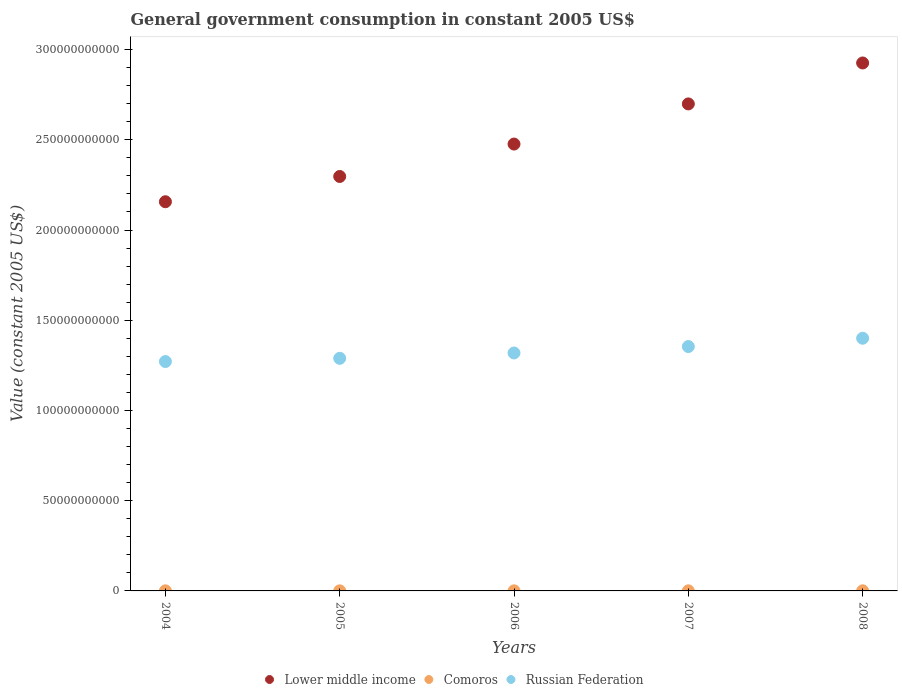Is the number of dotlines equal to the number of legend labels?
Your answer should be very brief. Yes. What is the government conusmption in Comoros in 2005?
Provide a short and direct response. 4.92e+07. Across all years, what is the maximum government conusmption in Lower middle income?
Ensure brevity in your answer.  2.93e+11. Across all years, what is the minimum government conusmption in Comoros?
Ensure brevity in your answer.  4.92e+07. In which year was the government conusmption in Lower middle income maximum?
Provide a succinct answer. 2008. In which year was the government conusmption in Lower middle income minimum?
Your answer should be very brief. 2004. What is the total government conusmption in Russian Federation in the graph?
Your answer should be compact. 6.63e+11. What is the difference between the government conusmption in Lower middle income in 2006 and that in 2007?
Give a very brief answer. -2.22e+1. What is the difference between the government conusmption in Russian Federation in 2004 and the government conusmption in Comoros in 2008?
Keep it short and to the point. 1.27e+11. What is the average government conusmption in Lower middle income per year?
Provide a short and direct response. 2.51e+11. In the year 2007, what is the difference between the government conusmption in Russian Federation and government conusmption in Comoros?
Provide a succinct answer. 1.35e+11. In how many years, is the government conusmption in Comoros greater than 30000000000 US$?
Your answer should be compact. 0. What is the ratio of the government conusmption in Comoros in 2007 to that in 2008?
Your answer should be very brief. 0.8. Is the government conusmption in Lower middle income in 2005 less than that in 2007?
Keep it short and to the point. Yes. What is the difference between the highest and the second highest government conusmption in Lower middle income?
Give a very brief answer. 2.27e+1. What is the difference between the highest and the lowest government conusmption in Lower middle income?
Offer a very short reply. 7.69e+1. In how many years, is the government conusmption in Comoros greater than the average government conusmption in Comoros taken over all years?
Keep it short and to the point. 2. Is the sum of the government conusmption in Russian Federation in 2004 and 2008 greater than the maximum government conusmption in Lower middle income across all years?
Your response must be concise. No. Is the government conusmption in Comoros strictly greater than the government conusmption in Russian Federation over the years?
Ensure brevity in your answer.  No. How many dotlines are there?
Provide a succinct answer. 3. How many years are there in the graph?
Provide a short and direct response. 5. What is the difference between two consecutive major ticks on the Y-axis?
Your answer should be compact. 5.00e+1. Are the values on the major ticks of Y-axis written in scientific E-notation?
Your answer should be compact. No. Does the graph contain grids?
Your answer should be compact. No. How many legend labels are there?
Your answer should be compact. 3. How are the legend labels stacked?
Your answer should be very brief. Horizontal. What is the title of the graph?
Offer a terse response. General government consumption in constant 2005 US$. What is the label or title of the Y-axis?
Offer a terse response. Value (constant 2005 US$). What is the Value (constant 2005 US$) of Lower middle income in 2004?
Offer a very short reply. 2.16e+11. What is the Value (constant 2005 US$) of Comoros in 2004?
Offer a very short reply. 5.04e+07. What is the Value (constant 2005 US$) in Russian Federation in 2004?
Provide a short and direct response. 1.27e+11. What is the Value (constant 2005 US$) in Lower middle income in 2005?
Keep it short and to the point. 2.30e+11. What is the Value (constant 2005 US$) of Comoros in 2005?
Ensure brevity in your answer.  4.92e+07. What is the Value (constant 2005 US$) in Russian Federation in 2005?
Provide a short and direct response. 1.29e+11. What is the Value (constant 2005 US$) in Lower middle income in 2006?
Offer a very short reply. 2.48e+11. What is the Value (constant 2005 US$) in Comoros in 2006?
Offer a very short reply. 4.92e+07. What is the Value (constant 2005 US$) in Russian Federation in 2006?
Your answer should be compact. 1.32e+11. What is the Value (constant 2005 US$) in Lower middle income in 2007?
Make the answer very short. 2.70e+11. What is the Value (constant 2005 US$) of Comoros in 2007?
Your answer should be compact. 5.63e+07. What is the Value (constant 2005 US$) in Russian Federation in 2007?
Your response must be concise. 1.35e+11. What is the Value (constant 2005 US$) in Lower middle income in 2008?
Your answer should be compact. 2.93e+11. What is the Value (constant 2005 US$) in Comoros in 2008?
Ensure brevity in your answer.  7.03e+07. What is the Value (constant 2005 US$) of Russian Federation in 2008?
Keep it short and to the point. 1.40e+11. Across all years, what is the maximum Value (constant 2005 US$) of Lower middle income?
Offer a terse response. 2.93e+11. Across all years, what is the maximum Value (constant 2005 US$) of Comoros?
Your answer should be compact. 7.03e+07. Across all years, what is the maximum Value (constant 2005 US$) in Russian Federation?
Give a very brief answer. 1.40e+11. Across all years, what is the minimum Value (constant 2005 US$) in Lower middle income?
Give a very brief answer. 2.16e+11. Across all years, what is the minimum Value (constant 2005 US$) of Comoros?
Your response must be concise. 4.92e+07. Across all years, what is the minimum Value (constant 2005 US$) of Russian Federation?
Give a very brief answer. 1.27e+11. What is the total Value (constant 2005 US$) in Lower middle income in the graph?
Provide a succinct answer. 1.26e+12. What is the total Value (constant 2005 US$) in Comoros in the graph?
Offer a very short reply. 2.75e+08. What is the total Value (constant 2005 US$) of Russian Federation in the graph?
Make the answer very short. 6.63e+11. What is the difference between the Value (constant 2005 US$) in Lower middle income in 2004 and that in 2005?
Your response must be concise. -1.40e+1. What is the difference between the Value (constant 2005 US$) of Comoros in 2004 and that in 2005?
Offer a terse response. 1.22e+06. What is the difference between the Value (constant 2005 US$) in Russian Federation in 2004 and that in 2005?
Provide a short and direct response. -1.78e+09. What is the difference between the Value (constant 2005 US$) of Lower middle income in 2004 and that in 2006?
Provide a short and direct response. -3.20e+1. What is the difference between the Value (constant 2005 US$) in Comoros in 2004 and that in 2006?
Give a very brief answer. 1.20e+06. What is the difference between the Value (constant 2005 US$) in Russian Federation in 2004 and that in 2006?
Keep it short and to the point. -4.74e+09. What is the difference between the Value (constant 2005 US$) of Lower middle income in 2004 and that in 2007?
Provide a short and direct response. -5.42e+1. What is the difference between the Value (constant 2005 US$) of Comoros in 2004 and that in 2007?
Make the answer very short. -5.85e+06. What is the difference between the Value (constant 2005 US$) of Russian Federation in 2004 and that in 2007?
Your response must be concise. -8.30e+09. What is the difference between the Value (constant 2005 US$) in Lower middle income in 2004 and that in 2008?
Make the answer very short. -7.69e+1. What is the difference between the Value (constant 2005 US$) of Comoros in 2004 and that in 2008?
Give a very brief answer. -1.99e+07. What is the difference between the Value (constant 2005 US$) of Russian Federation in 2004 and that in 2008?
Give a very brief answer. -1.29e+1. What is the difference between the Value (constant 2005 US$) in Lower middle income in 2005 and that in 2006?
Provide a succinct answer. -1.80e+1. What is the difference between the Value (constant 2005 US$) of Comoros in 2005 and that in 2006?
Offer a very short reply. -2.12e+04. What is the difference between the Value (constant 2005 US$) in Russian Federation in 2005 and that in 2006?
Provide a succinct answer. -2.96e+09. What is the difference between the Value (constant 2005 US$) in Lower middle income in 2005 and that in 2007?
Provide a succinct answer. -4.02e+1. What is the difference between the Value (constant 2005 US$) of Comoros in 2005 and that in 2007?
Your answer should be compact. -7.07e+06. What is the difference between the Value (constant 2005 US$) of Russian Federation in 2005 and that in 2007?
Give a very brief answer. -6.53e+09. What is the difference between the Value (constant 2005 US$) in Lower middle income in 2005 and that in 2008?
Provide a succinct answer. -6.29e+1. What is the difference between the Value (constant 2005 US$) of Comoros in 2005 and that in 2008?
Offer a very short reply. -2.11e+07. What is the difference between the Value (constant 2005 US$) of Russian Federation in 2005 and that in 2008?
Ensure brevity in your answer.  -1.11e+1. What is the difference between the Value (constant 2005 US$) in Lower middle income in 2006 and that in 2007?
Keep it short and to the point. -2.22e+1. What is the difference between the Value (constant 2005 US$) in Comoros in 2006 and that in 2007?
Your answer should be compact. -7.05e+06. What is the difference between the Value (constant 2005 US$) in Russian Federation in 2006 and that in 2007?
Provide a short and direct response. -3.56e+09. What is the difference between the Value (constant 2005 US$) in Lower middle income in 2006 and that in 2008?
Offer a very short reply. -4.49e+1. What is the difference between the Value (constant 2005 US$) of Comoros in 2006 and that in 2008?
Your response must be concise. -2.11e+07. What is the difference between the Value (constant 2005 US$) in Russian Federation in 2006 and that in 2008?
Ensure brevity in your answer.  -8.16e+09. What is the difference between the Value (constant 2005 US$) of Lower middle income in 2007 and that in 2008?
Make the answer very short. -2.27e+1. What is the difference between the Value (constant 2005 US$) in Comoros in 2007 and that in 2008?
Your answer should be compact. -1.41e+07. What is the difference between the Value (constant 2005 US$) in Russian Federation in 2007 and that in 2008?
Give a very brief answer. -4.60e+09. What is the difference between the Value (constant 2005 US$) of Lower middle income in 2004 and the Value (constant 2005 US$) of Comoros in 2005?
Provide a succinct answer. 2.16e+11. What is the difference between the Value (constant 2005 US$) in Lower middle income in 2004 and the Value (constant 2005 US$) in Russian Federation in 2005?
Your response must be concise. 8.68e+1. What is the difference between the Value (constant 2005 US$) in Comoros in 2004 and the Value (constant 2005 US$) in Russian Federation in 2005?
Ensure brevity in your answer.  -1.29e+11. What is the difference between the Value (constant 2005 US$) of Lower middle income in 2004 and the Value (constant 2005 US$) of Comoros in 2006?
Ensure brevity in your answer.  2.16e+11. What is the difference between the Value (constant 2005 US$) of Lower middle income in 2004 and the Value (constant 2005 US$) of Russian Federation in 2006?
Your answer should be compact. 8.38e+1. What is the difference between the Value (constant 2005 US$) of Comoros in 2004 and the Value (constant 2005 US$) of Russian Federation in 2006?
Keep it short and to the point. -1.32e+11. What is the difference between the Value (constant 2005 US$) in Lower middle income in 2004 and the Value (constant 2005 US$) in Comoros in 2007?
Make the answer very short. 2.16e+11. What is the difference between the Value (constant 2005 US$) of Lower middle income in 2004 and the Value (constant 2005 US$) of Russian Federation in 2007?
Offer a very short reply. 8.02e+1. What is the difference between the Value (constant 2005 US$) in Comoros in 2004 and the Value (constant 2005 US$) in Russian Federation in 2007?
Your response must be concise. -1.35e+11. What is the difference between the Value (constant 2005 US$) of Lower middle income in 2004 and the Value (constant 2005 US$) of Comoros in 2008?
Make the answer very short. 2.16e+11. What is the difference between the Value (constant 2005 US$) in Lower middle income in 2004 and the Value (constant 2005 US$) in Russian Federation in 2008?
Your response must be concise. 7.56e+1. What is the difference between the Value (constant 2005 US$) of Comoros in 2004 and the Value (constant 2005 US$) of Russian Federation in 2008?
Your answer should be very brief. -1.40e+11. What is the difference between the Value (constant 2005 US$) in Lower middle income in 2005 and the Value (constant 2005 US$) in Comoros in 2006?
Provide a succinct answer. 2.30e+11. What is the difference between the Value (constant 2005 US$) in Lower middle income in 2005 and the Value (constant 2005 US$) in Russian Federation in 2006?
Offer a very short reply. 9.78e+1. What is the difference between the Value (constant 2005 US$) of Comoros in 2005 and the Value (constant 2005 US$) of Russian Federation in 2006?
Your answer should be very brief. -1.32e+11. What is the difference between the Value (constant 2005 US$) of Lower middle income in 2005 and the Value (constant 2005 US$) of Comoros in 2007?
Keep it short and to the point. 2.30e+11. What is the difference between the Value (constant 2005 US$) of Lower middle income in 2005 and the Value (constant 2005 US$) of Russian Federation in 2007?
Provide a succinct answer. 9.43e+1. What is the difference between the Value (constant 2005 US$) of Comoros in 2005 and the Value (constant 2005 US$) of Russian Federation in 2007?
Ensure brevity in your answer.  -1.35e+11. What is the difference between the Value (constant 2005 US$) in Lower middle income in 2005 and the Value (constant 2005 US$) in Comoros in 2008?
Keep it short and to the point. 2.30e+11. What is the difference between the Value (constant 2005 US$) of Lower middle income in 2005 and the Value (constant 2005 US$) of Russian Federation in 2008?
Your response must be concise. 8.96e+1. What is the difference between the Value (constant 2005 US$) of Comoros in 2005 and the Value (constant 2005 US$) of Russian Federation in 2008?
Your answer should be compact. -1.40e+11. What is the difference between the Value (constant 2005 US$) in Lower middle income in 2006 and the Value (constant 2005 US$) in Comoros in 2007?
Your answer should be very brief. 2.48e+11. What is the difference between the Value (constant 2005 US$) of Lower middle income in 2006 and the Value (constant 2005 US$) of Russian Federation in 2007?
Offer a very short reply. 1.12e+11. What is the difference between the Value (constant 2005 US$) in Comoros in 2006 and the Value (constant 2005 US$) in Russian Federation in 2007?
Provide a succinct answer. -1.35e+11. What is the difference between the Value (constant 2005 US$) in Lower middle income in 2006 and the Value (constant 2005 US$) in Comoros in 2008?
Ensure brevity in your answer.  2.48e+11. What is the difference between the Value (constant 2005 US$) of Lower middle income in 2006 and the Value (constant 2005 US$) of Russian Federation in 2008?
Keep it short and to the point. 1.08e+11. What is the difference between the Value (constant 2005 US$) of Comoros in 2006 and the Value (constant 2005 US$) of Russian Federation in 2008?
Offer a terse response. -1.40e+11. What is the difference between the Value (constant 2005 US$) of Lower middle income in 2007 and the Value (constant 2005 US$) of Comoros in 2008?
Your response must be concise. 2.70e+11. What is the difference between the Value (constant 2005 US$) in Lower middle income in 2007 and the Value (constant 2005 US$) in Russian Federation in 2008?
Keep it short and to the point. 1.30e+11. What is the difference between the Value (constant 2005 US$) of Comoros in 2007 and the Value (constant 2005 US$) of Russian Federation in 2008?
Offer a terse response. -1.40e+11. What is the average Value (constant 2005 US$) of Lower middle income per year?
Keep it short and to the point. 2.51e+11. What is the average Value (constant 2005 US$) of Comoros per year?
Ensure brevity in your answer.  5.51e+07. What is the average Value (constant 2005 US$) of Russian Federation per year?
Provide a succinct answer. 1.33e+11. In the year 2004, what is the difference between the Value (constant 2005 US$) of Lower middle income and Value (constant 2005 US$) of Comoros?
Your response must be concise. 2.16e+11. In the year 2004, what is the difference between the Value (constant 2005 US$) of Lower middle income and Value (constant 2005 US$) of Russian Federation?
Offer a very short reply. 8.86e+1. In the year 2004, what is the difference between the Value (constant 2005 US$) of Comoros and Value (constant 2005 US$) of Russian Federation?
Offer a very short reply. -1.27e+11. In the year 2005, what is the difference between the Value (constant 2005 US$) of Lower middle income and Value (constant 2005 US$) of Comoros?
Provide a succinct answer. 2.30e+11. In the year 2005, what is the difference between the Value (constant 2005 US$) in Lower middle income and Value (constant 2005 US$) in Russian Federation?
Give a very brief answer. 1.01e+11. In the year 2005, what is the difference between the Value (constant 2005 US$) of Comoros and Value (constant 2005 US$) of Russian Federation?
Offer a terse response. -1.29e+11. In the year 2006, what is the difference between the Value (constant 2005 US$) of Lower middle income and Value (constant 2005 US$) of Comoros?
Your answer should be very brief. 2.48e+11. In the year 2006, what is the difference between the Value (constant 2005 US$) of Lower middle income and Value (constant 2005 US$) of Russian Federation?
Give a very brief answer. 1.16e+11. In the year 2006, what is the difference between the Value (constant 2005 US$) of Comoros and Value (constant 2005 US$) of Russian Federation?
Provide a succinct answer. -1.32e+11. In the year 2007, what is the difference between the Value (constant 2005 US$) in Lower middle income and Value (constant 2005 US$) in Comoros?
Offer a very short reply. 2.70e+11. In the year 2007, what is the difference between the Value (constant 2005 US$) of Lower middle income and Value (constant 2005 US$) of Russian Federation?
Ensure brevity in your answer.  1.34e+11. In the year 2007, what is the difference between the Value (constant 2005 US$) in Comoros and Value (constant 2005 US$) in Russian Federation?
Your answer should be very brief. -1.35e+11. In the year 2008, what is the difference between the Value (constant 2005 US$) of Lower middle income and Value (constant 2005 US$) of Comoros?
Your response must be concise. 2.93e+11. In the year 2008, what is the difference between the Value (constant 2005 US$) in Lower middle income and Value (constant 2005 US$) in Russian Federation?
Provide a succinct answer. 1.53e+11. In the year 2008, what is the difference between the Value (constant 2005 US$) of Comoros and Value (constant 2005 US$) of Russian Federation?
Ensure brevity in your answer.  -1.40e+11. What is the ratio of the Value (constant 2005 US$) in Lower middle income in 2004 to that in 2005?
Offer a very short reply. 0.94. What is the ratio of the Value (constant 2005 US$) in Comoros in 2004 to that in 2005?
Make the answer very short. 1.02. What is the ratio of the Value (constant 2005 US$) in Russian Federation in 2004 to that in 2005?
Keep it short and to the point. 0.99. What is the ratio of the Value (constant 2005 US$) of Lower middle income in 2004 to that in 2006?
Your answer should be very brief. 0.87. What is the ratio of the Value (constant 2005 US$) of Comoros in 2004 to that in 2006?
Your answer should be very brief. 1.02. What is the ratio of the Value (constant 2005 US$) of Lower middle income in 2004 to that in 2007?
Make the answer very short. 0.8. What is the ratio of the Value (constant 2005 US$) of Comoros in 2004 to that in 2007?
Offer a terse response. 0.9. What is the ratio of the Value (constant 2005 US$) in Russian Federation in 2004 to that in 2007?
Your answer should be compact. 0.94. What is the ratio of the Value (constant 2005 US$) in Lower middle income in 2004 to that in 2008?
Offer a terse response. 0.74. What is the ratio of the Value (constant 2005 US$) of Comoros in 2004 to that in 2008?
Make the answer very short. 0.72. What is the ratio of the Value (constant 2005 US$) in Russian Federation in 2004 to that in 2008?
Provide a succinct answer. 0.91. What is the ratio of the Value (constant 2005 US$) of Lower middle income in 2005 to that in 2006?
Give a very brief answer. 0.93. What is the ratio of the Value (constant 2005 US$) in Comoros in 2005 to that in 2006?
Ensure brevity in your answer.  1. What is the ratio of the Value (constant 2005 US$) of Russian Federation in 2005 to that in 2006?
Offer a terse response. 0.98. What is the ratio of the Value (constant 2005 US$) of Lower middle income in 2005 to that in 2007?
Provide a short and direct response. 0.85. What is the ratio of the Value (constant 2005 US$) of Comoros in 2005 to that in 2007?
Your response must be concise. 0.87. What is the ratio of the Value (constant 2005 US$) in Russian Federation in 2005 to that in 2007?
Your answer should be compact. 0.95. What is the ratio of the Value (constant 2005 US$) in Lower middle income in 2005 to that in 2008?
Offer a very short reply. 0.79. What is the ratio of the Value (constant 2005 US$) of Comoros in 2005 to that in 2008?
Give a very brief answer. 0.7. What is the ratio of the Value (constant 2005 US$) of Russian Federation in 2005 to that in 2008?
Make the answer very short. 0.92. What is the ratio of the Value (constant 2005 US$) in Lower middle income in 2006 to that in 2007?
Provide a succinct answer. 0.92. What is the ratio of the Value (constant 2005 US$) in Comoros in 2006 to that in 2007?
Provide a short and direct response. 0.87. What is the ratio of the Value (constant 2005 US$) in Russian Federation in 2006 to that in 2007?
Make the answer very short. 0.97. What is the ratio of the Value (constant 2005 US$) of Lower middle income in 2006 to that in 2008?
Provide a succinct answer. 0.85. What is the ratio of the Value (constant 2005 US$) in Comoros in 2006 to that in 2008?
Give a very brief answer. 0.7. What is the ratio of the Value (constant 2005 US$) of Russian Federation in 2006 to that in 2008?
Your answer should be very brief. 0.94. What is the ratio of the Value (constant 2005 US$) of Lower middle income in 2007 to that in 2008?
Your response must be concise. 0.92. What is the ratio of the Value (constant 2005 US$) of Comoros in 2007 to that in 2008?
Your answer should be compact. 0.8. What is the ratio of the Value (constant 2005 US$) in Russian Federation in 2007 to that in 2008?
Keep it short and to the point. 0.97. What is the difference between the highest and the second highest Value (constant 2005 US$) in Lower middle income?
Your answer should be very brief. 2.27e+1. What is the difference between the highest and the second highest Value (constant 2005 US$) of Comoros?
Your answer should be compact. 1.41e+07. What is the difference between the highest and the second highest Value (constant 2005 US$) in Russian Federation?
Offer a terse response. 4.60e+09. What is the difference between the highest and the lowest Value (constant 2005 US$) of Lower middle income?
Your answer should be compact. 7.69e+1. What is the difference between the highest and the lowest Value (constant 2005 US$) in Comoros?
Give a very brief answer. 2.11e+07. What is the difference between the highest and the lowest Value (constant 2005 US$) in Russian Federation?
Ensure brevity in your answer.  1.29e+1. 